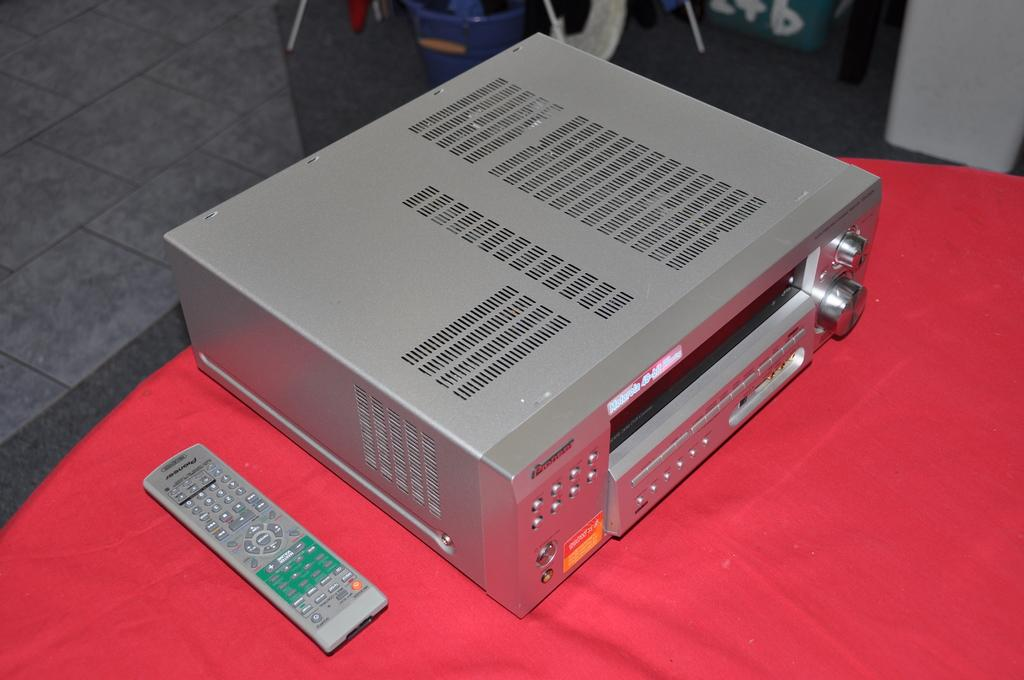<image>
Write a terse but informative summary of the picture. A Pioneer grey electronic machine, box-like and with knobs and buttons, next to its remote on top of a red tablecloth. 